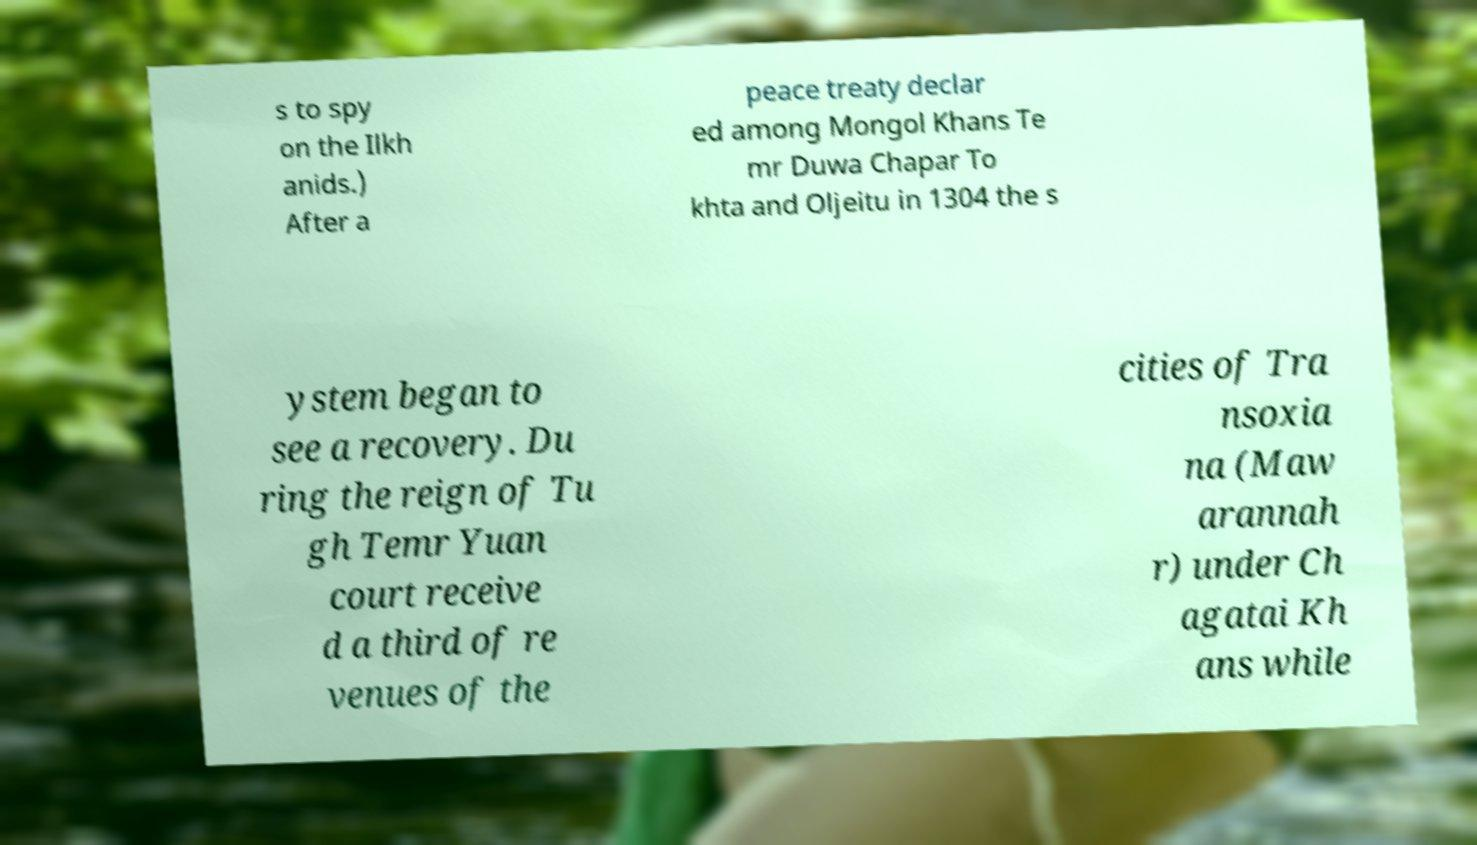Could you extract and type out the text from this image? s to spy on the Ilkh anids.) After a peace treaty declar ed among Mongol Khans Te mr Duwa Chapar To khta and Oljeitu in 1304 the s ystem began to see a recovery. Du ring the reign of Tu gh Temr Yuan court receive d a third of re venues of the cities of Tra nsoxia na (Maw arannah r) under Ch agatai Kh ans while 